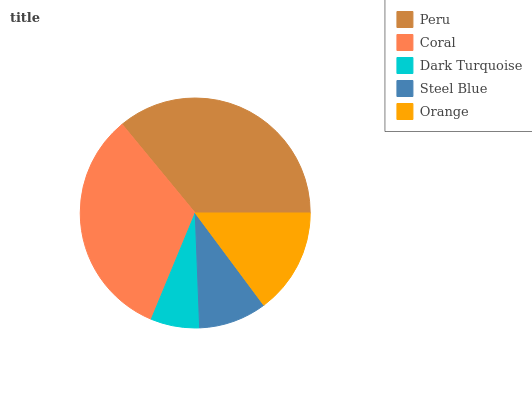Is Dark Turquoise the minimum?
Answer yes or no. Yes. Is Peru the maximum?
Answer yes or no. Yes. Is Coral the minimum?
Answer yes or no. No. Is Coral the maximum?
Answer yes or no. No. Is Peru greater than Coral?
Answer yes or no. Yes. Is Coral less than Peru?
Answer yes or no. Yes. Is Coral greater than Peru?
Answer yes or no. No. Is Peru less than Coral?
Answer yes or no. No. Is Orange the high median?
Answer yes or no. Yes. Is Orange the low median?
Answer yes or no. Yes. Is Coral the high median?
Answer yes or no. No. Is Dark Turquoise the low median?
Answer yes or no. No. 